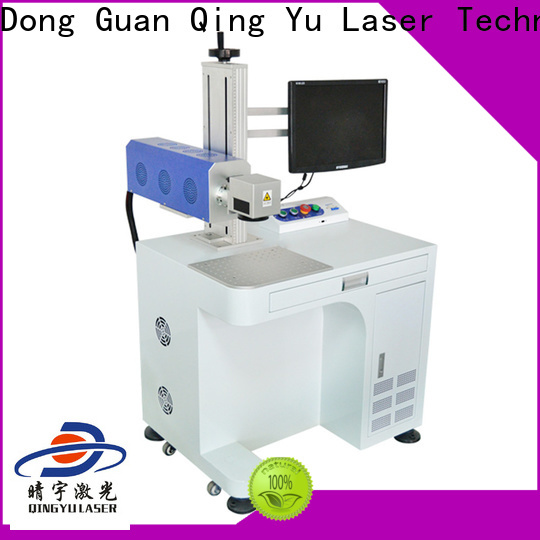Imagine the engraving machine is part of an advanced automated assembly line. What role could it play, and how would it interact with other machines on the line? In an advanced automated assembly line, this laser engraving machine could play a pivotal role in marking and identification tasks. As products proceed through the assembly line, the machine could automatically engrave necessary information such as serial numbers, product codes, logos, and other identifiers. It would likely be integrated with a central control system that coordinates the entire assembly line, receiving information about each product and the specific engraving required. The machine could also interact with robotic arms that position products correctly for engraving, ensuring precision and efficiency. This integration would facilitate seamless, high-speed engraving operations without manual intervention, enhancing overall productivity and traceability in the manufacturing process. Could you envision a scenario where this machine is used in a futuristic factory? Absolutely, in a futuristic factory setting, this laser engraving machine could be part of a highly sophisticated and intelligent manufacturing ecosystem. Imagine a scenario where products are rapidly 3D-printed by other advanced machines and then moved via intelligent conveyor systems to the laser engraver. Using AI and IoT technology, the engraver could receive real-time data on each product, automatically adjusting its settings to engrave complex, customized designs or information unique to each item. The machine could communicate with a central AI that ensures optimal efficiency, predicts maintenance needs, and dynamically alters the production line to prevent downtime. This futuristic setup would epitomize the pinnacle of smart manufacturing, where flexibility, precision, and efficiency are maximized through interconnected, autonomous systems. 